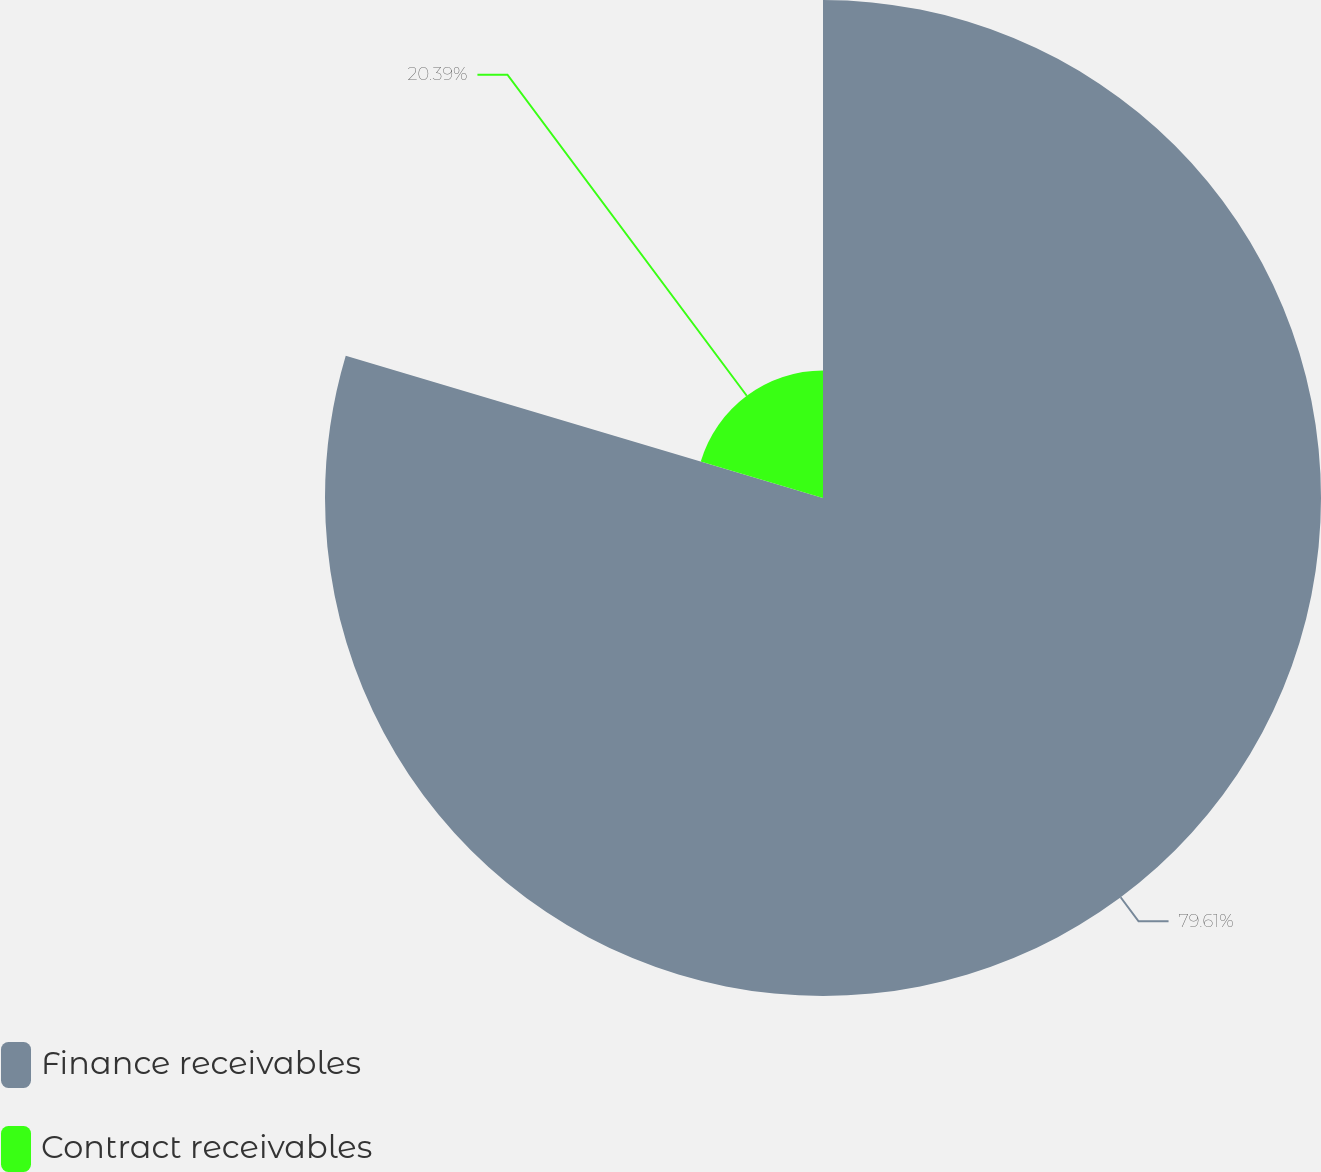Convert chart. <chart><loc_0><loc_0><loc_500><loc_500><pie_chart><fcel>Finance receivables<fcel>Contract receivables<nl><fcel>79.61%<fcel>20.39%<nl></chart> 